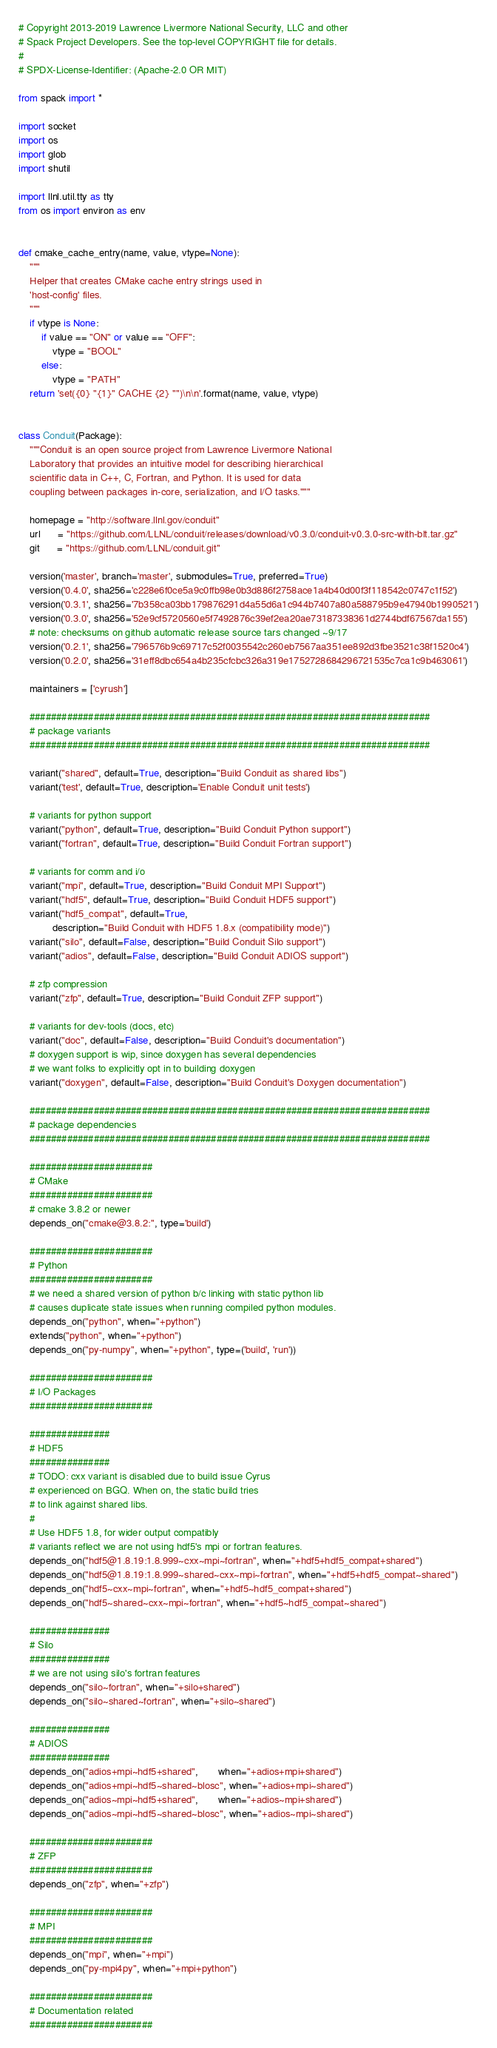Convert code to text. <code><loc_0><loc_0><loc_500><loc_500><_Python_># Copyright 2013-2019 Lawrence Livermore National Security, LLC and other
# Spack Project Developers. See the top-level COPYRIGHT file for details.
#
# SPDX-License-Identifier: (Apache-2.0 OR MIT)

from spack import *

import socket
import os
import glob
import shutil

import llnl.util.tty as tty
from os import environ as env


def cmake_cache_entry(name, value, vtype=None):
    """
    Helper that creates CMake cache entry strings used in
    'host-config' files.
    """
    if vtype is None:
        if value == "ON" or value == "OFF":
            vtype = "BOOL"
        else:
            vtype = "PATH"
    return 'set({0} "{1}" CACHE {2} "")\n\n'.format(name, value, vtype)


class Conduit(Package):
    """Conduit is an open source project from Lawrence Livermore National
    Laboratory that provides an intuitive model for describing hierarchical
    scientific data in C++, C, Fortran, and Python. It is used for data
    coupling between packages in-core, serialization, and I/O tasks."""

    homepage = "http://software.llnl.gov/conduit"
    url      = "https://github.com/LLNL/conduit/releases/download/v0.3.0/conduit-v0.3.0-src-with-blt.tar.gz"
    git      = "https://github.com/LLNL/conduit.git"

    version('master', branch='master', submodules=True, preferred=True)
    version('0.4.0', sha256='c228e6f0ce5a9c0ffb98e0b3d886f2758ace1a4b40d00f3f118542c0747c1f52')
    version('0.3.1', sha256='7b358ca03bb179876291d4a55d6a1c944b7407a80a588795b9e47940b1990521')
    version('0.3.0', sha256='52e9cf5720560e5f7492876c39ef2ea20ae73187338361d2744bdf67567da155')
    # note: checksums on github automatic release source tars changed ~9/17
    version('0.2.1', sha256='796576b9c69717c52f0035542c260eb7567aa351ee892d3fbe3521c38f1520c4')
    version('0.2.0', sha256='31eff8dbc654a4b235cfcbc326a319e1752728684296721535c7ca1c9b463061')

    maintainers = ['cyrush']

    ###########################################################################
    # package variants
    ###########################################################################

    variant("shared", default=True, description="Build Conduit as shared libs")
    variant('test', default=True, description='Enable Conduit unit tests')

    # variants for python support
    variant("python", default=True, description="Build Conduit Python support")
    variant("fortran", default=True, description="Build Conduit Fortran support")

    # variants for comm and i/o
    variant("mpi", default=True, description="Build Conduit MPI Support")
    variant("hdf5", default=True, description="Build Conduit HDF5 support")
    variant("hdf5_compat", default=True,
            description="Build Conduit with HDF5 1.8.x (compatibility mode)")
    variant("silo", default=False, description="Build Conduit Silo support")
    variant("adios", default=False, description="Build Conduit ADIOS support")

    # zfp compression
    variant("zfp", default=True, description="Build Conduit ZFP support")

    # variants for dev-tools (docs, etc)
    variant("doc", default=False, description="Build Conduit's documentation")
    # doxygen support is wip, since doxygen has several dependencies
    # we want folks to explicitly opt in to building doxygen
    variant("doxygen", default=False, description="Build Conduit's Doxygen documentation")

    ###########################################################################
    # package dependencies
    ###########################################################################

    #######################
    # CMake
    #######################
    # cmake 3.8.2 or newer
    depends_on("cmake@3.8.2:", type='build')

    #######################
    # Python
    #######################
    # we need a shared version of python b/c linking with static python lib
    # causes duplicate state issues when running compiled python modules.
    depends_on("python", when="+python")
    extends("python", when="+python")
    depends_on("py-numpy", when="+python", type=('build', 'run'))

    #######################
    # I/O Packages
    #######################

    ###############
    # HDF5
    ###############
    # TODO: cxx variant is disabled due to build issue Cyrus
    # experienced on BGQ. When on, the static build tries
    # to link against shared libs.
    #
    # Use HDF5 1.8, for wider output compatibly
    # variants reflect we are not using hdf5's mpi or fortran features.
    depends_on("hdf5@1.8.19:1.8.999~cxx~mpi~fortran", when="+hdf5+hdf5_compat+shared")
    depends_on("hdf5@1.8.19:1.8.999~shared~cxx~mpi~fortran", when="+hdf5+hdf5_compat~shared")
    depends_on("hdf5~cxx~mpi~fortran", when="+hdf5~hdf5_compat+shared")
    depends_on("hdf5~shared~cxx~mpi~fortran", when="+hdf5~hdf5_compat~shared")

    ###############
    # Silo
    ###############
    # we are not using silo's fortran features
    depends_on("silo~fortran", when="+silo+shared")
    depends_on("silo~shared~fortran", when="+silo~shared")

    ###############
    # ADIOS
    ###############
    depends_on("adios+mpi~hdf5+shared",       when="+adios+mpi+shared")
    depends_on("adios+mpi~hdf5~shared~blosc", when="+adios+mpi~shared")
    depends_on("adios~mpi~hdf5+shared",       when="+adios~mpi+shared")
    depends_on("adios~mpi~hdf5~shared~blosc", when="+adios~mpi~shared")

    #######################
    # ZFP
    #######################
    depends_on("zfp", when="+zfp")

    #######################
    # MPI
    #######################
    depends_on("mpi", when="+mpi")
    depends_on("py-mpi4py", when="+mpi+python")

    #######################
    # Documentation related
    #######################</code> 